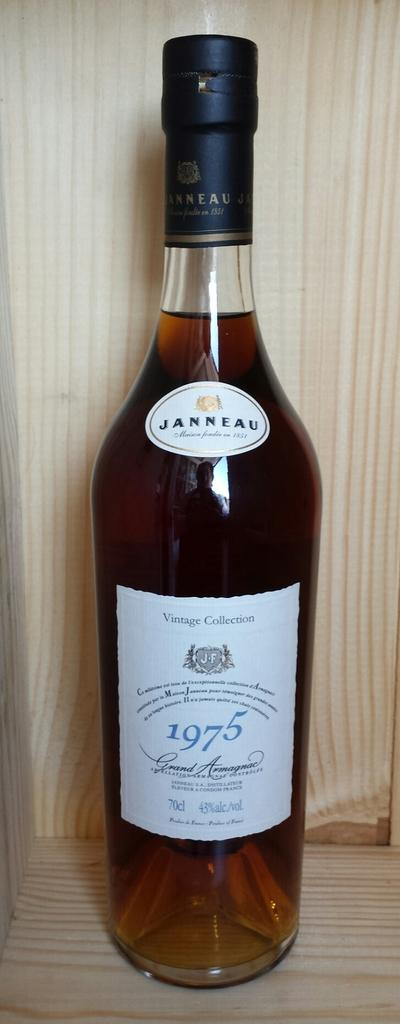<image>
Write a terse but informative summary of the picture. A bottle of Janneau liquor is 43% alcohol. 